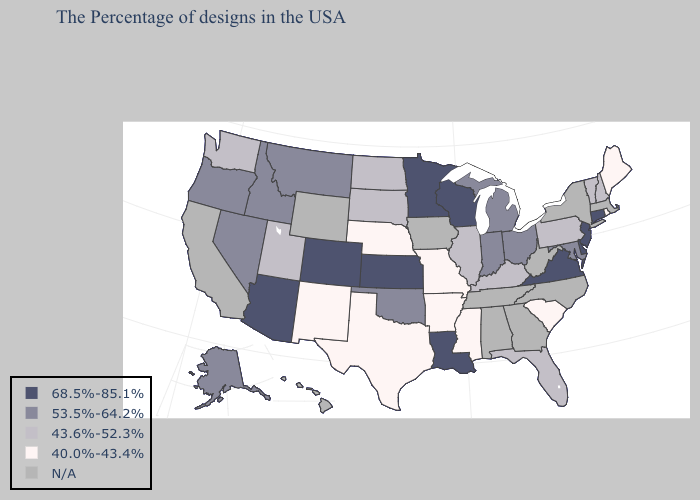Name the states that have a value in the range 53.5%-64.2%?
Keep it brief. Maryland, Ohio, Michigan, Indiana, Oklahoma, Montana, Idaho, Nevada, Oregon, Alaska. Name the states that have a value in the range 68.5%-85.1%?
Answer briefly. Connecticut, New Jersey, Delaware, Virginia, Wisconsin, Louisiana, Minnesota, Kansas, Colorado, Arizona. Name the states that have a value in the range N/A?
Answer briefly. Massachusetts, New York, North Carolina, West Virginia, Georgia, Alabama, Tennessee, Iowa, Wyoming, California, Hawaii. Does New Hampshire have the lowest value in the Northeast?
Quick response, please. No. Name the states that have a value in the range 40.0%-43.4%?
Keep it brief. Maine, Rhode Island, South Carolina, Mississippi, Missouri, Arkansas, Nebraska, Texas, New Mexico. Name the states that have a value in the range 53.5%-64.2%?
Concise answer only. Maryland, Ohio, Michigan, Indiana, Oklahoma, Montana, Idaho, Nevada, Oregon, Alaska. Name the states that have a value in the range 40.0%-43.4%?
Quick response, please. Maine, Rhode Island, South Carolina, Mississippi, Missouri, Arkansas, Nebraska, Texas, New Mexico. Does the first symbol in the legend represent the smallest category?
Be succinct. No. What is the value of Maryland?
Answer briefly. 53.5%-64.2%. What is the value of South Dakota?
Short answer required. 43.6%-52.3%. Name the states that have a value in the range N/A?
Quick response, please. Massachusetts, New York, North Carolina, West Virginia, Georgia, Alabama, Tennessee, Iowa, Wyoming, California, Hawaii. Which states hav the highest value in the MidWest?
Answer briefly. Wisconsin, Minnesota, Kansas. Among the states that border Oklahoma , which have the highest value?
Short answer required. Kansas, Colorado. How many symbols are there in the legend?
Quick response, please. 5. 